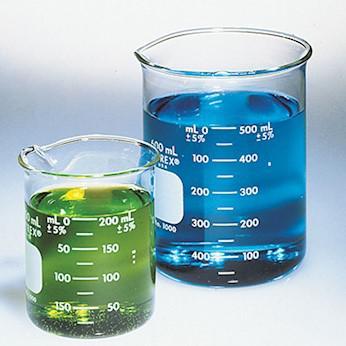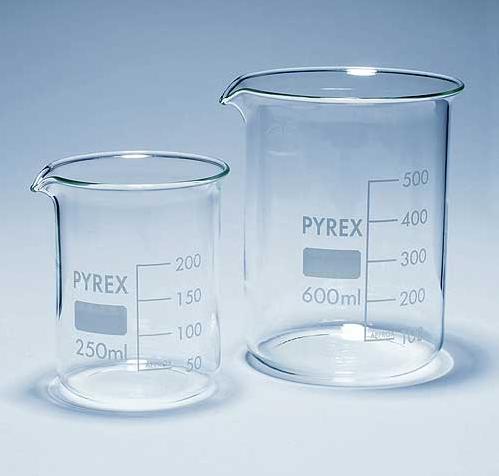The first image is the image on the left, the second image is the image on the right. Considering the images on both sides, is "The image on the left has three beakers and the smallest one has a pink fluid." valid? Answer yes or no. No. 